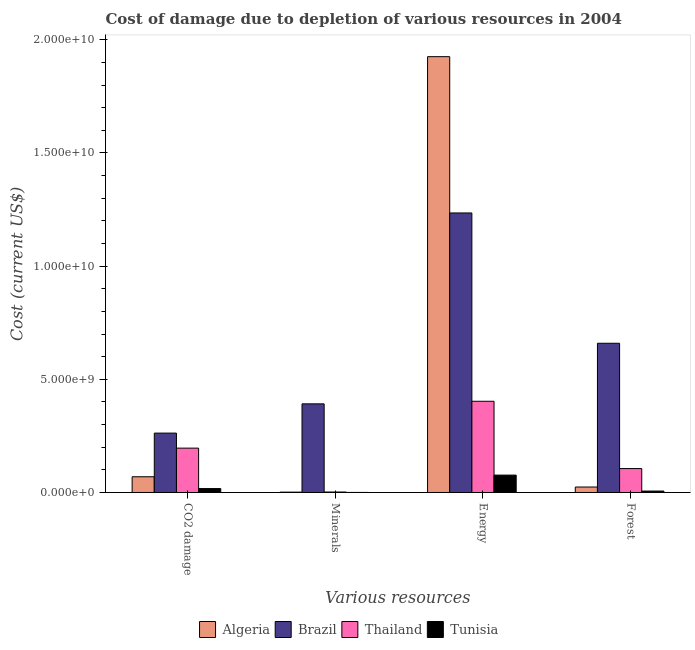How many different coloured bars are there?
Your answer should be very brief. 4. How many bars are there on the 2nd tick from the right?
Your answer should be very brief. 4. What is the label of the 1st group of bars from the left?
Give a very brief answer. CO2 damage. What is the cost of damage due to depletion of energy in Thailand?
Ensure brevity in your answer.  4.03e+09. Across all countries, what is the maximum cost of damage due to depletion of forests?
Make the answer very short. 6.59e+09. Across all countries, what is the minimum cost of damage due to depletion of coal?
Your answer should be compact. 1.73e+08. In which country was the cost of damage due to depletion of energy maximum?
Make the answer very short. Algeria. In which country was the cost of damage due to depletion of coal minimum?
Your answer should be compact. Tunisia. What is the total cost of damage due to depletion of forests in the graph?
Your answer should be very brief. 7.95e+09. What is the difference between the cost of damage due to depletion of coal in Tunisia and that in Thailand?
Your response must be concise. -1.79e+09. What is the difference between the cost of damage due to depletion of forests in Thailand and the cost of damage due to depletion of energy in Brazil?
Ensure brevity in your answer.  -1.13e+1. What is the average cost of damage due to depletion of energy per country?
Give a very brief answer. 9.10e+09. What is the difference between the cost of damage due to depletion of forests and cost of damage due to depletion of coal in Brazil?
Offer a terse response. 3.97e+09. In how many countries, is the cost of damage due to depletion of minerals greater than 14000000000 US$?
Your answer should be compact. 0. What is the ratio of the cost of damage due to depletion of coal in Brazil to that in Tunisia?
Offer a very short reply. 15.15. What is the difference between the highest and the second highest cost of damage due to depletion of energy?
Give a very brief answer. 6.91e+09. What is the difference between the highest and the lowest cost of damage due to depletion of energy?
Your answer should be compact. 1.85e+1. In how many countries, is the cost of damage due to depletion of coal greater than the average cost of damage due to depletion of coal taken over all countries?
Keep it short and to the point. 2. What does the 4th bar from the left in Energy represents?
Offer a terse response. Tunisia. What does the 1st bar from the right in Minerals represents?
Ensure brevity in your answer.  Tunisia. Is it the case that in every country, the sum of the cost of damage due to depletion of coal and cost of damage due to depletion of minerals is greater than the cost of damage due to depletion of energy?
Give a very brief answer. No. How many bars are there?
Offer a terse response. 16. Are the values on the major ticks of Y-axis written in scientific E-notation?
Give a very brief answer. Yes. Does the graph contain any zero values?
Give a very brief answer. No. Does the graph contain grids?
Your response must be concise. No. Where does the legend appear in the graph?
Keep it short and to the point. Bottom center. How many legend labels are there?
Offer a very short reply. 4. What is the title of the graph?
Provide a succinct answer. Cost of damage due to depletion of various resources in 2004 . What is the label or title of the X-axis?
Make the answer very short. Various resources. What is the label or title of the Y-axis?
Your answer should be very brief. Cost (current US$). What is the Cost (current US$) in Algeria in CO2 damage?
Your answer should be very brief. 6.95e+08. What is the Cost (current US$) in Brazil in CO2 damage?
Offer a terse response. 2.62e+09. What is the Cost (current US$) in Thailand in CO2 damage?
Offer a terse response. 1.96e+09. What is the Cost (current US$) in Tunisia in CO2 damage?
Keep it short and to the point. 1.73e+08. What is the Cost (current US$) of Algeria in Minerals?
Offer a very short reply. 1.56e+07. What is the Cost (current US$) of Brazil in Minerals?
Ensure brevity in your answer.  3.92e+09. What is the Cost (current US$) in Thailand in Minerals?
Offer a terse response. 2.08e+07. What is the Cost (current US$) of Tunisia in Minerals?
Ensure brevity in your answer.  2.32e+06. What is the Cost (current US$) in Algeria in Energy?
Offer a terse response. 1.93e+1. What is the Cost (current US$) of Brazil in Energy?
Offer a terse response. 1.24e+1. What is the Cost (current US$) of Thailand in Energy?
Your response must be concise. 4.03e+09. What is the Cost (current US$) of Tunisia in Energy?
Offer a very short reply. 7.68e+08. What is the Cost (current US$) of Algeria in Forest?
Provide a short and direct response. 2.41e+08. What is the Cost (current US$) of Brazil in Forest?
Give a very brief answer. 6.59e+09. What is the Cost (current US$) in Thailand in Forest?
Your answer should be very brief. 1.06e+09. What is the Cost (current US$) in Tunisia in Forest?
Your answer should be very brief. 6.31e+07. Across all Various resources, what is the maximum Cost (current US$) of Algeria?
Give a very brief answer. 1.93e+1. Across all Various resources, what is the maximum Cost (current US$) of Brazil?
Provide a succinct answer. 1.24e+1. Across all Various resources, what is the maximum Cost (current US$) in Thailand?
Provide a short and direct response. 4.03e+09. Across all Various resources, what is the maximum Cost (current US$) in Tunisia?
Your answer should be very brief. 7.68e+08. Across all Various resources, what is the minimum Cost (current US$) in Algeria?
Your response must be concise. 1.56e+07. Across all Various resources, what is the minimum Cost (current US$) of Brazil?
Offer a very short reply. 2.62e+09. Across all Various resources, what is the minimum Cost (current US$) in Thailand?
Your answer should be compact. 2.08e+07. Across all Various resources, what is the minimum Cost (current US$) of Tunisia?
Offer a very short reply. 2.32e+06. What is the total Cost (current US$) of Algeria in the graph?
Your answer should be very brief. 2.02e+1. What is the total Cost (current US$) in Brazil in the graph?
Offer a very short reply. 2.55e+1. What is the total Cost (current US$) of Thailand in the graph?
Provide a short and direct response. 7.07e+09. What is the total Cost (current US$) of Tunisia in the graph?
Your answer should be compact. 1.01e+09. What is the difference between the Cost (current US$) of Algeria in CO2 damage and that in Minerals?
Make the answer very short. 6.80e+08. What is the difference between the Cost (current US$) in Brazil in CO2 damage and that in Minerals?
Your response must be concise. -1.29e+09. What is the difference between the Cost (current US$) of Thailand in CO2 damage and that in Minerals?
Provide a short and direct response. 1.94e+09. What is the difference between the Cost (current US$) in Tunisia in CO2 damage and that in Minerals?
Provide a succinct answer. 1.71e+08. What is the difference between the Cost (current US$) of Algeria in CO2 damage and that in Energy?
Offer a terse response. -1.86e+1. What is the difference between the Cost (current US$) in Brazil in CO2 damage and that in Energy?
Keep it short and to the point. -9.73e+09. What is the difference between the Cost (current US$) of Thailand in CO2 damage and that in Energy?
Offer a very short reply. -2.07e+09. What is the difference between the Cost (current US$) of Tunisia in CO2 damage and that in Energy?
Your answer should be compact. -5.95e+08. What is the difference between the Cost (current US$) in Algeria in CO2 damage and that in Forest?
Offer a terse response. 4.54e+08. What is the difference between the Cost (current US$) in Brazil in CO2 damage and that in Forest?
Make the answer very short. -3.97e+09. What is the difference between the Cost (current US$) of Thailand in CO2 damage and that in Forest?
Your answer should be compact. 9.03e+08. What is the difference between the Cost (current US$) in Tunisia in CO2 damage and that in Forest?
Make the answer very short. 1.10e+08. What is the difference between the Cost (current US$) in Algeria in Minerals and that in Energy?
Provide a succinct answer. -1.92e+1. What is the difference between the Cost (current US$) in Brazil in Minerals and that in Energy?
Offer a very short reply. -8.43e+09. What is the difference between the Cost (current US$) in Thailand in Minerals and that in Energy?
Offer a terse response. -4.01e+09. What is the difference between the Cost (current US$) of Tunisia in Minerals and that in Energy?
Make the answer very short. -7.66e+08. What is the difference between the Cost (current US$) of Algeria in Minerals and that in Forest?
Give a very brief answer. -2.26e+08. What is the difference between the Cost (current US$) of Brazil in Minerals and that in Forest?
Ensure brevity in your answer.  -2.68e+09. What is the difference between the Cost (current US$) of Thailand in Minerals and that in Forest?
Provide a succinct answer. -1.04e+09. What is the difference between the Cost (current US$) of Tunisia in Minerals and that in Forest?
Keep it short and to the point. -6.08e+07. What is the difference between the Cost (current US$) of Algeria in Energy and that in Forest?
Give a very brief answer. 1.90e+1. What is the difference between the Cost (current US$) in Brazil in Energy and that in Forest?
Ensure brevity in your answer.  5.76e+09. What is the difference between the Cost (current US$) of Thailand in Energy and that in Forest?
Keep it short and to the point. 2.97e+09. What is the difference between the Cost (current US$) of Tunisia in Energy and that in Forest?
Provide a short and direct response. 7.05e+08. What is the difference between the Cost (current US$) in Algeria in CO2 damage and the Cost (current US$) in Brazil in Minerals?
Make the answer very short. -3.22e+09. What is the difference between the Cost (current US$) in Algeria in CO2 damage and the Cost (current US$) in Thailand in Minerals?
Keep it short and to the point. 6.74e+08. What is the difference between the Cost (current US$) of Algeria in CO2 damage and the Cost (current US$) of Tunisia in Minerals?
Make the answer very short. 6.93e+08. What is the difference between the Cost (current US$) of Brazil in CO2 damage and the Cost (current US$) of Thailand in Minerals?
Offer a terse response. 2.60e+09. What is the difference between the Cost (current US$) in Brazil in CO2 damage and the Cost (current US$) in Tunisia in Minerals?
Offer a very short reply. 2.62e+09. What is the difference between the Cost (current US$) in Thailand in CO2 damage and the Cost (current US$) in Tunisia in Minerals?
Give a very brief answer. 1.96e+09. What is the difference between the Cost (current US$) of Algeria in CO2 damage and the Cost (current US$) of Brazil in Energy?
Provide a succinct answer. -1.17e+1. What is the difference between the Cost (current US$) of Algeria in CO2 damage and the Cost (current US$) of Thailand in Energy?
Offer a very short reply. -3.34e+09. What is the difference between the Cost (current US$) in Algeria in CO2 damage and the Cost (current US$) in Tunisia in Energy?
Make the answer very short. -7.31e+07. What is the difference between the Cost (current US$) of Brazil in CO2 damage and the Cost (current US$) of Thailand in Energy?
Offer a terse response. -1.41e+09. What is the difference between the Cost (current US$) of Brazil in CO2 damage and the Cost (current US$) of Tunisia in Energy?
Make the answer very short. 1.86e+09. What is the difference between the Cost (current US$) in Thailand in CO2 damage and the Cost (current US$) in Tunisia in Energy?
Your response must be concise. 1.19e+09. What is the difference between the Cost (current US$) in Algeria in CO2 damage and the Cost (current US$) in Brazil in Forest?
Ensure brevity in your answer.  -5.90e+09. What is the difference between the Cost (current US$) of Algeria in CO2 damage and the Cost (current US$) of Thailand in Forest?
Keep it short and to the point. -3.62e+08. What is the difference between the Cost (current US$) of Algeria in CO2 damage and the Cost (current US$) of Tunisia in Forest?
Offer a very short reply. 6.32e+08. What is the difference between the Cost (current US$) in Brazil in CO2 damage and the Cost (current US$) in Thailand in Forest?
Ensure brevity in your answer.  1.57e+09. What is the difference between the Cost (current US$) in Brazil in CO2 damage and the Cost (current US$) in Tunisia in Forest?
Ensure brevity in your answer.  2.56e+09. What is the difference between the Cost (current US$) in Thailand in CO2 damage and the Cost (current US$) in Tunisia in Forest?
Give a very brief answer. 1.90e+09. What is the difference between the Cost (current US$) in Algeria in Minerals and the Cost (current US$) in Brazil in Energy?
Keep it short and to the point. -1.23e+1. What is the difference between the Cost (current US$) of Algeria in Minerals and the Cost (current US$) of Thailand in Energy?
Provide a succinct answer. -4.01e+09. What is the difference between the Cost (current US$) of Algeria in Minerals and the Cost (current US$) of Tunisia in Energy?
Your response must be concise. -7.53e+08. What is the difference between the Cost (current US$) of Brazil in Minerals and the Cost (current US$) of Thailand in Energy?
Your response must be concise. -1.14e+08. What is the difference between the Cost (current US$) in Brazil in Minerals and the Cost (current US$) in Tunisia in Energy?
Give a very brief answer. 3.15e+09. What is the difference between the Cost (current US$) of Thailand in Minerals and the Cost (current US$) of Tunisia in Energy?
Keep it short and to the point. -7.47e+08. What is the difference between the Cost (current US$) of Algeria in Minerals and the Cost (current US$) of Brazil in Forest?
Make the answer very short. -6.58e+09. What is the difference between the Cost (current US$) in Algeria in Minerals and the Cost (current US$) in Thailand in Forest?
Give a very brief answer. -1.04e+09. What is the difference between the Cost (current US$) in Algeria in Minerals and the Cost (current US$) in Tunisia in Forest?
Provide a short and direct response. -4.75e+07. What is the difference between the Cost (current US$) of Brazil in Minerals and the Cost (current US$) of Thailand in Forest?
Make the answer very short. 2.86e+09. What is the difference between the Cost (current US$) in Brazil in Minerals and the Cost (current US$) in Tunisia in Forest?
Your answer should be very brief. 3.85e+09. What is the difference between the Cost (current US$) in Thailand in Minerals and the Cost (current US$) in Tunisia in Forest?
Keep it short and to the point. -4.23e+07. What is the difference between the Cost (current US$) of Algeria in Energy and the Cost (current US$) of Brazil in Forest?
Your response must be concise. 1.27e+1. What is the difference between the Cost (current US$) of Algeria in Energy and the Cost (current US$) of Thailand in Forest?
Offer a very short reply. 1.82e+1. What is the difference between the Cost (current US$) in Algeria in Energy and the Cost (current US$) in Tunisia in Forest?
Give a very brief answer. 1.92e+1. What is the difference between the Cost (current US$) of Brazil in Energy and the Cost (current US$) of Thailand in Forest?
Your answer should be very brief. 1.13e+1. What is the difference between the Cost (current US$) in Brazil in Energy and the Cost (current US$) in Tunisia in Forest?
Your answer should be very brief. 1.23e+1. What is the difference between the Cost (current US$) in Thailand in Energy and the Cost (current US$) in Tunisia in Forest?
Your response must be concise. 3.97e+09. What is the average Cost (current US$) in Algeria per Various resources?
Offer a terse response. 5.05e+09. What is the average Cost (current US$) of Brazil per Various resources?
Give a very brief answer. 6.37e+09. What is the average Cost (current US$) in Thailand per Various resources?
Offer a very short reply. 1.77e+09. What is the average Cost (current US$) of Tunisia per Various resources?
Keep it short and to the point. 2.52e+08. What is the difference between the Cost (current US$) in Algeria and Cost (current US$) in Brazil in CO2 damage?
Your response must be concise. -1.93e+09. What is the difference between the Cost (current US$) in Algeria and Cost (current US$) in Thailand in CO2 damage?
Give a very brief answer. -1.26e+09. What is the difference between the Cost (current US$) of Algeria and Cost (current US$) of Tunisia in CO2 damage?
Provide a succinct answer. 5.22e+08. What is the difference between the Cost (current US$) of Brazil and Cost (current US$) of Thailand in CO2 damage?
Your answer should be compact. 6.64e+08. What is the difference between the Cost (current US$) of Brazil and Cost (current US$) of Tunisia in CO2 damage?
Offer a very short reply. 2.45e+09. What is the difference between the Cost (current US$) of Thailand and Cost (current US$) of Tunisia in CO2 damage?
Provide a succinct answer. 1.79e+09. What is the difference between the Cost (current US$) of Algeria and Cost (current US$) of Brazil in Minerals?
Provide a short and direct response. -3.90e+09. What is the difference between the Cost (current US$) in Algeria and Cost (current US$) in Thailand in Minerals?
Keep it short and to the point. -5.21e+06. What is the difference between the Cost (current US$) in Algeria and Cost (current US$) in Tunisia in Minerals?
Your response must be concise. 1.33e+07. What is the difference between the Cost (current US$) in Brazil and Cost (current US$) in Thailand in Minerals?
Offer a terse response. 3.90e+09. What is the difference between the Cost (current US$) in Brazil and Cost (current US$) in Tunisia in Minerals?
Provide a succinct answer. 3.91e+09. What is the difference between the Cost (current US$) of Thailand and Cost (current US$) of Tunisia in Minerals?
Keep it short and to the point. 1.85e+07. What is the difference between the Cost (current US$) in Algeria and Cost (current US$) in Brazil in Energy?
Keep it short and to the point. 6.91e+09. What is the difference between the Cost (current US$) of Algeria and Cost (current US$) of Thailand in Energy?
Your answer should be very brief. 1.52e+1. What is the difference between the Cost (current US$) of Algeria and Cost (current US$) of Tunisia in Energy?
Provide a short and direct response. 1.85e+1. What is the difference between the Cost (current US$) in Brazil and Cost (current US$) in Thailand in Energy?
Make the answer very short. 8.32e+09. What is the difference between the Cost (current US$) in Brazil and Cost (current US$) in Tunisia in Energy?
Keep it short and to the point. 1.16e+1. What is the difference between the Cost (current US$) in Thailand and Cost (current US$) in Tunisia in Energy?
Your answer should be very brief. 3.26e+09. What is the difference between the Cost (current US$) in Algeria and Cost (current US$) in Brazil in Forest?
Make the answer very short. -6.35e+09. What is the difference between the Cost (current US$) of Algeria and Cost (current US$) of Thailand in Forest?
Your answer should be compact. -8.16e+08. What is the difference between the Cost (current US$) of Algeria and Cost (current US$) of Tunisia in Forest?
Make the answer very short. 1.78e+08. What is the difference between the Cost (current US$) in Brazil and Cost (current US$) in Thailand in Forest?
Offer a very short reply. 5.54e+09. What is the difference between the Cost (current US$) in Brazil and Cost (current US$) in Tunisia in Forest?
Keep it short and to the point. 6.53e+09. What is the difference between the Cost (current US$) in Thailand and Cost (current US$) in Tunisia in Forest?
Give a very brief answer. 9.94e+08. What is the ratio of the Cost (current US$) in Algeria in CO2 damage to that in Minerals?
Your answer should be compact. 44.64. What is the ratio of the Cost (current US$) of Brazil in CO2 damage to that in Minerals?
Offer a terse response. 0.67. What is the ratio of the Cost (current US$) of Thailand in CO2 damage to that in Minerals?
Your answer should be very brief. 94.33. What is the ratio of the Cost (current US$) of Tunisia in CO2 damage to that in Minerals?
Your answer should be very brief. 74.74. What is the ratio of the Cost (current US$) of Algeria in CO2 damage to that in Energy?
Provide a short and direct response. 0.04. What is the ratio of the Cost (current US$) of Brazil in CO2 damage to that in Energy?
Provide a succinct answer. 0.21. What is the ratio of the Cost (current US$) of Thailand in CO2 damage to that in Energy?
Keep it short and to the point. 0.49. What is the ratio of the Cost (current US$) of Tunisia in CO2 damage to that in Energy?
Your answer should be compact. 0.23. What is the ratio of the Cost (current US$) in Algeria in CO2 damage to that in Forest?
Ensure brevity in your answer.  2.88. What is the ratio of the Cost (current US$) of Brazil in CO2 damage to that in Forest?
Your response must be concise. 0.4. What is the ratio of the Cost (current US$) of Thailand in CO2 damage to that in Forest?
Offer a very short reply. 1.85. What is the ratio of the Cost (current US$) of Tunisia in CO2 damage to that in Forest?
Ensure brevity in your answer.  2.75. What is the ratio of the Cost (current US$) in Algeria in Minerals to that in Energy?
Your answer should be compact. 0. What is the ratio of the Cost (current US$) in Brazil in Minerals to that in Energy?
Make the answer very short. 0.32. What is the ratio of the Cost (current US$) of Thailand in Minerals to that in Energy?
Give a very brief answer. 0.01. What is the ratio of the Cost (current US$) in Tunisia in Minerals to that in Energy?
Your answer should be very brief. 0. What is the ratio of the Cost (current US$) in Algeria in Minerals to that in Forest?
Your answer should be very brief. 0.06. What is the ratio of the Cost (current US$) of Brazil in Minerals to that in Forest?
Ensure brevity in your answer.  0.59. What is the ratio of the Cost (current US$) in Thailand in Minerals to that in Forest?
Provide a short and direct response. 0.02. What is the ratio of the Cost (current US$) of Tunisia in Minerals to that in Forest?
Your answer should be very brief. 0.04. What is the ratio of the Cost (current US$) of Algeria in Energy to that in Forest?
Provide a short and direct response. 79.79. What is the ratio of the Cost (current US$) in Brazil in Energy to that in Forest?
Provide a short and direct response. 1.87. What is the ratio of the Cost (current US$) in Thailand in Energy to that in Forest?
Your answer should be very brief. 3.81. What is the ratio of the Cost (current US$) of Tunisia in Energy to that in Forest?
Make the answer very short. 12.18. What is the difference between the highest and the second highest Cost (current US$) in Algeria?
Provide a short and direct response. 1.86e+1. What is the difference between the highest and the second highest Cost (current US$) of Brazil?
Ensure brevity in your answer.  5.76e+09. What is the difference between the highest and the second highest Cost (current US$) in Thailand?
Offer a very short reply. 2.07e+09. What is the difference between the highest and the second highest Cost (current US$) of Tunisia?
Make the answer very short. 5.95e+08. What is the difference between the highest and the lowest Cost (current US$) in Algeria?
Offer a terse response. 1.92e+1. What is the difference between the highest and the lowest Cost (current US$) in Brazil?
Your answer should be very brief. 9.73e+09. What is the difference between the highest and the lowest Cost (current US$) of Thailand?
Offer a terse response. 4.01e+09. What is the difference between the highest and the lowest Cost (current US$) of Tunisia?
Provide a succinct answer. 7.66e+08. 